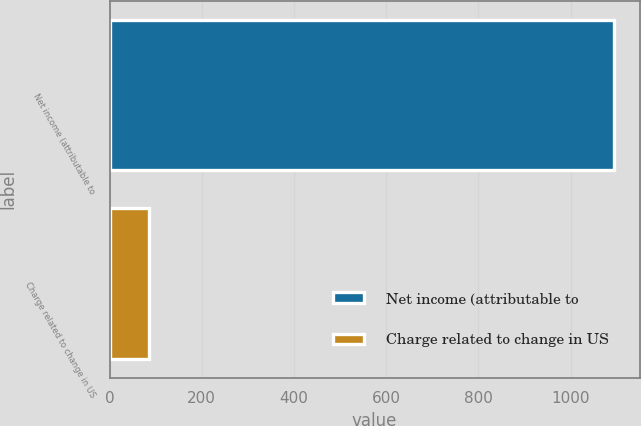<chart> <loc_0><loc_0><loc_500><loc_500><bar_chart><fcel>Net income (attributable to<fcel>Charge related to change in US<nl><fcel>1095<fcel>85<nl></chart> 